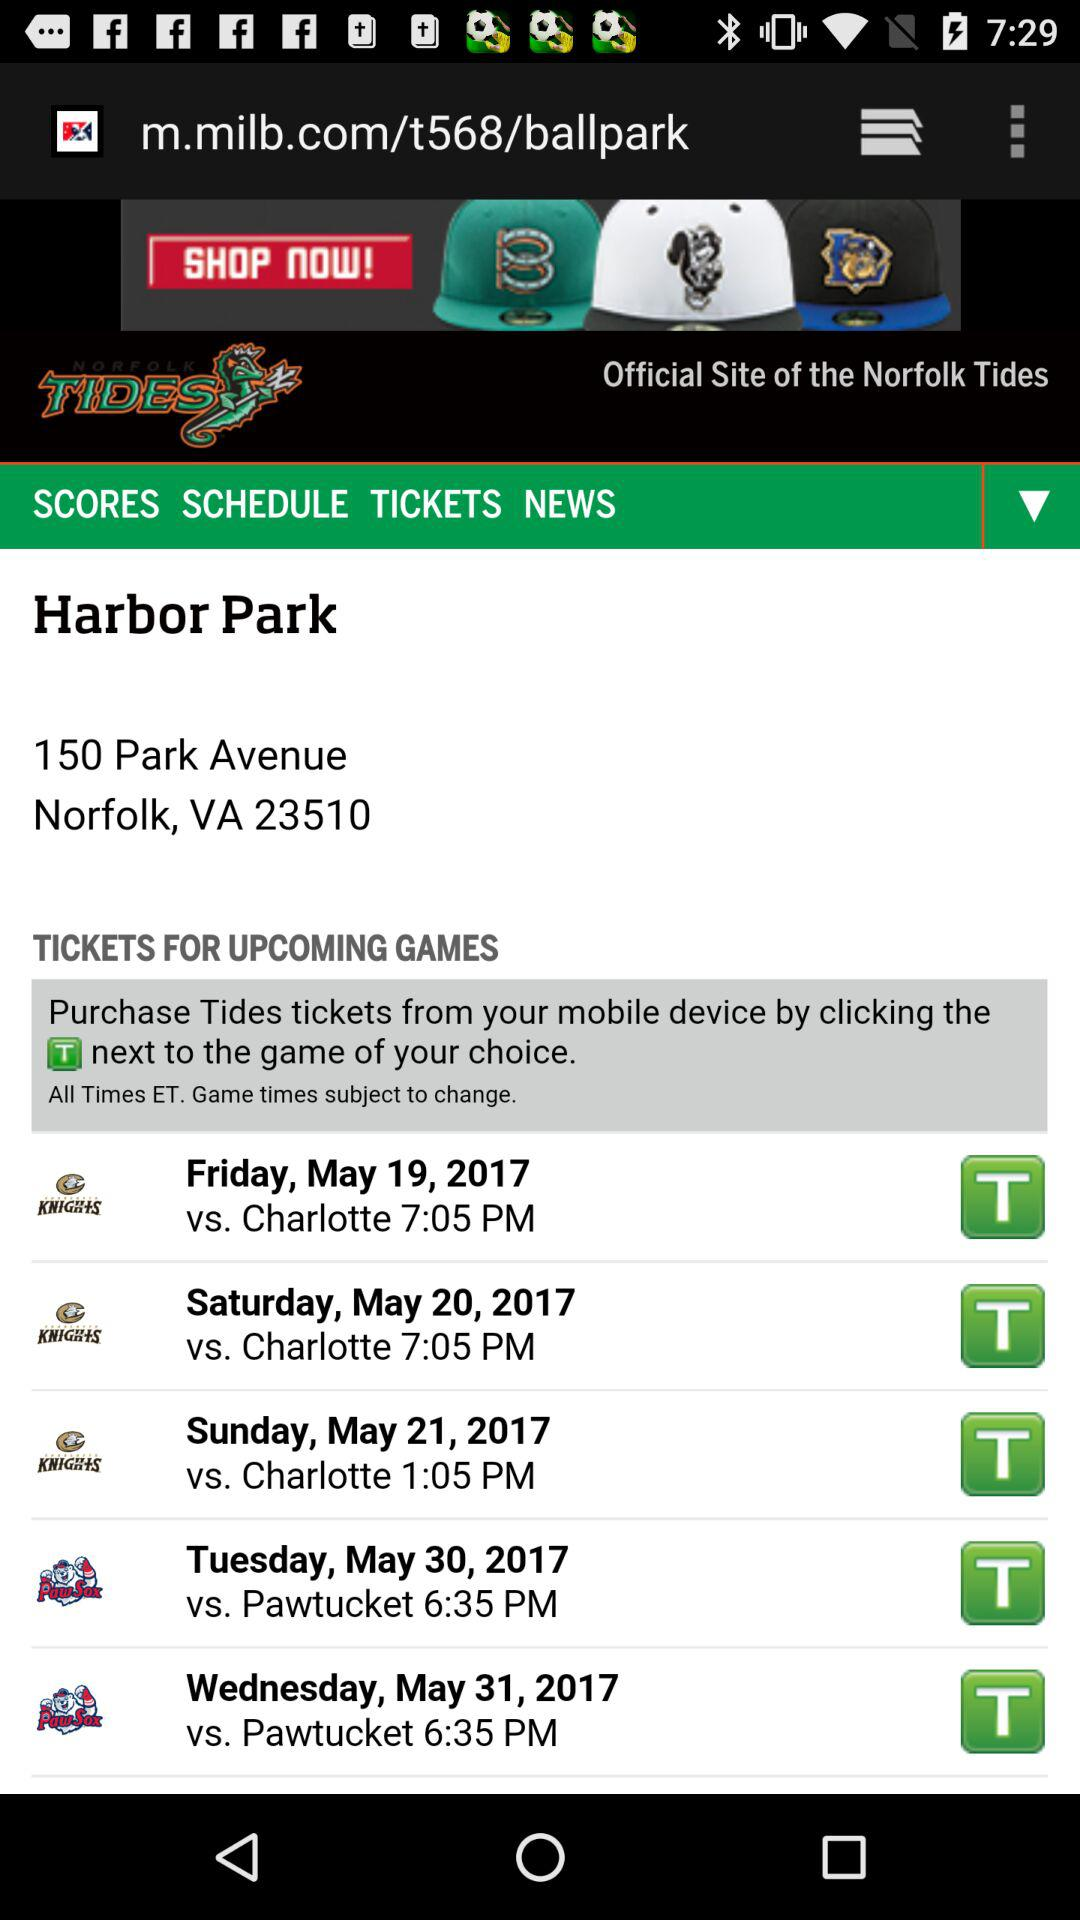How can we purchase the tide tickets? You can purchase tides tickets from your mobile device by clicking the T next to the game of your choice. 